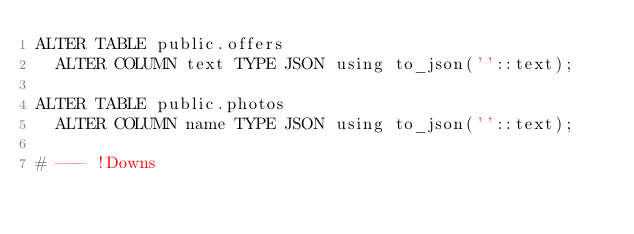<code> <loc_0><loc_0><loc_500><loc_500><_SQL_>ALTER TABLE public.offers
  ALTER COLUMN text TYPE JSON using to_json(''::text);

ALTER TABLE public.photos
  ALTER COLUMN name TYPE JSON using to_json(''::text);

# --- !Downs
</code> 